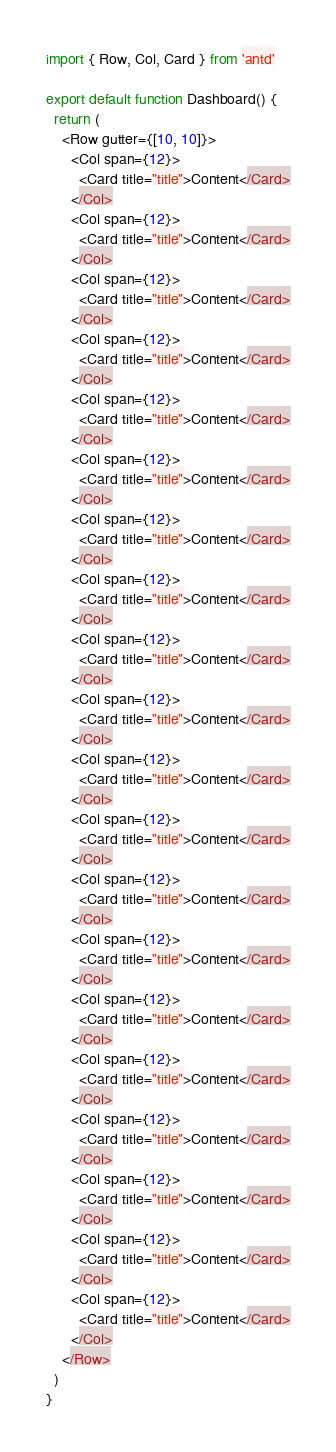Convert code to text. <code><loc_0><loc_0><loc_500><loc_500><_JavaScript_>import { Row, Col, Card } from 'antd'

export default function Dashboard() {
  return (
    <Row gutter={[10, 10]}>
      <Col span={12}>
        <Card title="title">Content</Card>
      </Col>
      <Col span={12}>
        <Card title="title">Content</Card>
      </Col>
      <Col span={12}>
        <Card title="title">Content</Card>
      </Col>
      <Col span={12}>
        <Card title="title">Content</Card>
      </Col>
      <Col span={12}>
        <Card title="title">Content</Card>
      </Col>
      <Col span={12}>
        <Card title="title">Content</Card>
      </Col>
      <Col span={12}>
        <Card title="title">Content</Card>
      </Col>
      <Col span={12}>
        <Card title="title">Content</Card>
      </Col>
      <Col span={12}>
        <Card title="title">Content</Card>
      </Col>
      <Col span={12}>
        <Card title="title">Content</Card>
      </Col>
      <Col span={12}>
        <Card title="title">Content</Card>
      </Col>
      <Col span={12}>
        <Card title="title">Content</Card>
      </Col>
      <Col span={12}>
        <Card title="title">Content</Card>
      </Col>
      <Col span={12}>
        <Card title="title">Content</Card>
      </Col>
      <Col span={12}>
        <Card title="title">Content</Card>
      </Col>
      <Col span={12}>
        <Card title="title">Content</Card>
      </Col>
      <Col span={12}>
        <Card title="title">Content</Card>
      </Col>
      <Col span={12}>
        <Card title="title">Content</Card>
      </Col>
      <Col span={12}>
        <Card title="title">Content</Card>
      </Col>
      <Col span={12}>
        <Card title="title">Content</Card>
      </Col>
    </Row>
  )
}
</code> 